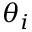<formula> <loc_0><loc_0><loc_500><loc_500>\theta _ { i }</formula> 